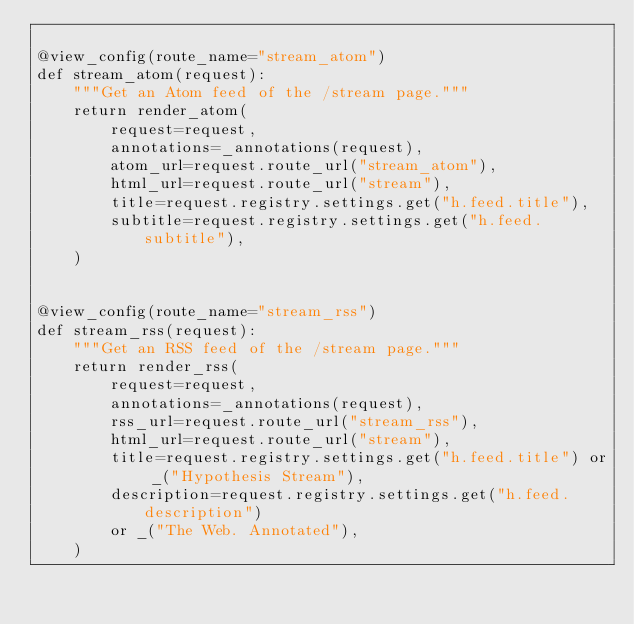<code> <loc_0><loc_0><loc_500><loc_500><_Python_>
@view_config(route_name="stream_atom")
def stream_atom(request):
    """Get an Atom feed of the /stream page."""
    return render_atom(
        request=request,
        annotations=_annotations(request),
        atom_url=request.route_url("stream_atom"),
        html_url=request.route_url("stream"),
        title=request.registry.settings.get("h.feed.title"),
        subtitle=request.registry.settings.get("h.feed.subtitle"),
    )


@view_config(route_name="stream_rss")
def stream_rss(request):
    """Get an RSS feed of the /stream page."""
    return render_rss(
        request=request,
        annotations=_annotations(request),
        rss_url=request.route_url("stream_rss"),
        html_url=request.route_url("stream"),
        title=request.registry.settings.get("h.feed.title") or _("Hypothesis Stream"),
        description=request.registry.settings.get("h.feed.description")
        or _("The Web. Annotated"),
    )
</code> 